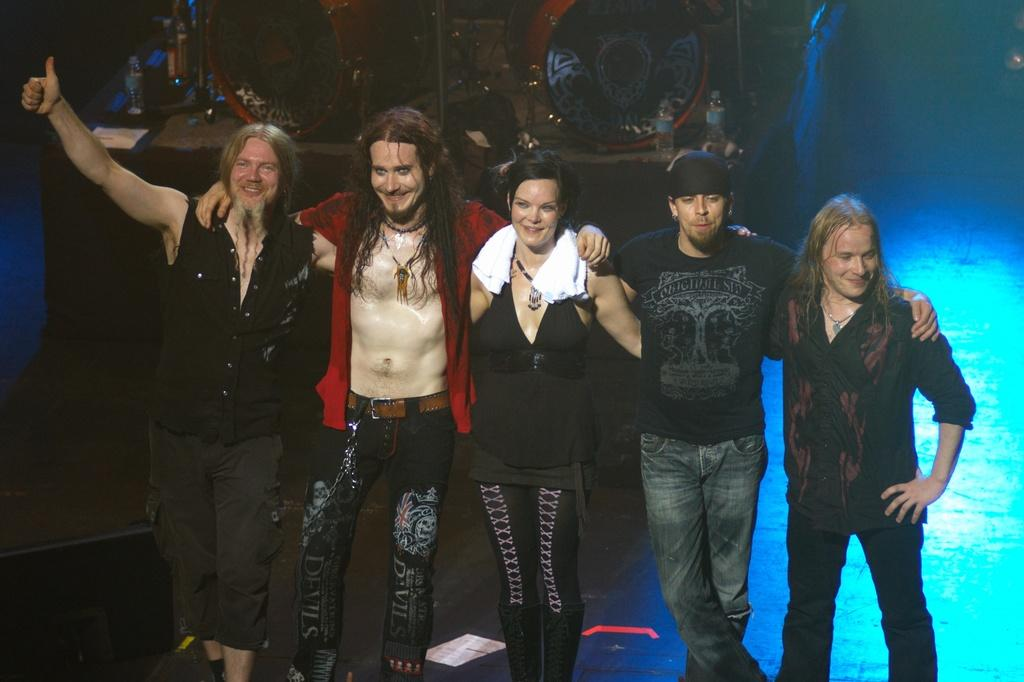How many people are standing in the image? There are five members standing in the image. What musical instruments can be seen in the image? There are drums visible in the image. What might the people in the image be using to stay hydrated? There are water bottles visible in the image. What type of fork can be seen being used to play the drums in the image? There is no fork present in the image, and forks are not used to play drums. What kind of structure is visible in the image? There is no specific structure mentioned in the provided facts; the image only mentions drums and water bottles. 